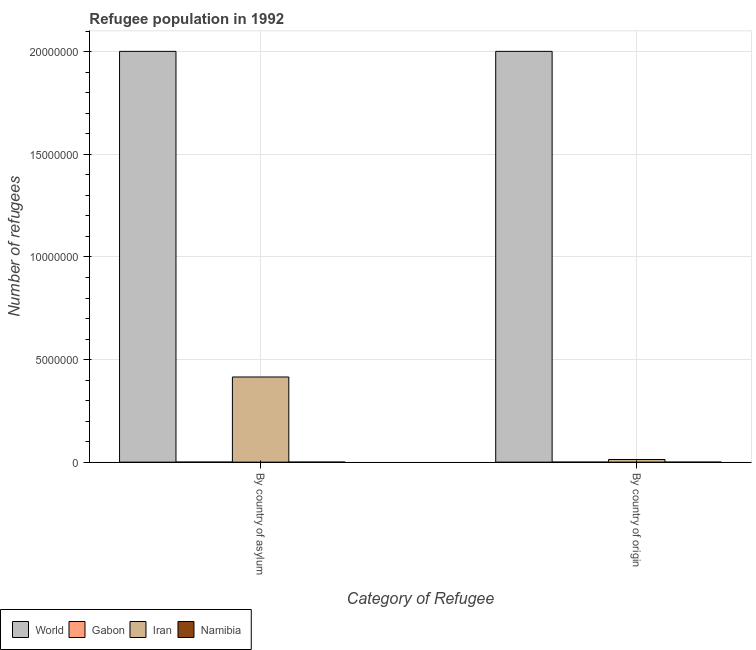How many groups of bars are there?
Make the answer very short. 2. Are the number of bars per tick equal to the number of legend labels?
Make the answer very short. Yes. Are the number of bars on each tick of the X-axis equal?
Your response must be concise. Yes. What is the label of the 1st group of bars from the left?
Your answer should be compact. By country of asylum. What is the number of refugees by country of asylum in Namibia?
Keep it short and to the point. 171. Across all countries, what is the maximum number of refugees by country of asylum?
Provide a succinct answer. 2.00e+07. Across all countries, what is the minimum number of refugees by country of origin?
Offer a terse response. 15. In which country was the number of refugees by country of origin maximum?
Make the answer very short. World. In which country was the number of refugees by country of asylum minimum?
Offer a terse response. Namibia. What is the total number of refugees by country of origin in the graph?
Your response must be concise. 2.02e+07. What is the difference between the number of refugees by country of origin in Gabon and that in World?
Offer a very short reply. -2.00e+07. What is the difference between the number of refugees by country of origin in Namibia and the number of refugees by country of asylum in World?
Ensure brevity in your answer.  -2.00e+07. What is the average number of refugees by country of origin per country?
Keep it short and to the point. 5.04e+06. What is the difference between the number of refugees by country of origin and number of refugees by country of asylum in Gabon?
Keep it short and to the point. -255. In how many countries, is the number of refugees by country of asylum greater than 8000000 ?
Offer a very short reply. 1. What is the ratio of the number of refugees by country of origin in Iran to that in Namibia?
Provide a succinct answer. 8585.4. In how many countries, is the number of refugees by country of origin greater than the average number of refugees by country of origin taken over all countries?
Ensure brevity in your answer.  1. What does the 2nd bar from the left in By country of asylum represents?
Give a very brief answer. Gabon. What does the 2nd bar from the right in By country of origin represents?
Give a very brief answer. Iran. How many bars are there?
Offer a very short reply. 8. Are all the bars in the graph horizontal?
Your answer should be compact. No. Are the values on the major ticks of Y-axis written in scientific E-notation?
Make the answer very short. No. Does the graph contain any zero values?
Ensure brevity in your answer.  No. Where does the legend appear in the graph?
Keep it short and to the point. Bottom left. How many legend labels are there?
Provide a succinct answer. 4. What is the title of the graph?
Ensure brevity in your answer.  Refugee population in 1992. Does "Tuvalu" appear as one of the legend labels in the graph?
Offer a very short reply. No. What is the label or title of the X-axis?
Make the answer very short. Category of Refugee. What is the label or title of the Y-axis?
Your answer should be compact. Number of refugees. What is the Number of refugees in World in By country of asylum?
Your answer should be compact. 2.00e+07. What is the Number of refugees in Gabon in By country of asylum?
Provide a succinct answer. 272. What is the Number of refugees of Iran in By country of asylum?
Keep it short and to the point. 4.15e+06. What is the Number of refugees of Namibia in By country of asylum?
Your response must be concise. 171. What is the Number of refugees in World in By country of origin?
Give a very brief answer. 2.00e+07. What is the Number of refugees of Gabon in By country of origin?
Ensure brevity in your answer.  17. What is the Number of refugees of Iran in By country of origin?
Ensure brevity in your answer.  1.29e+05. What is the Number of refugees in Namibia in By country of origin?
Make the answer very short. 15. Across all Category of Refugee, what is the maximum Number of refugees of World?
Your answer should be very brief. 2.00e+07. Across all Category of Refugee, what is the maximum Number of refugees in Gabon?
Provide a short and direct response. 272. Across all Category of Refugee, what is the maximum Number of refugees of Iran?
Offer a terse response. 4.15e+06. Across all Category of Refugee, what is the maximum Number of refugees in Namibia?
Make the answer very short. 171. Across all Category of Refugee, what is the minimum Number of refugees of World?
Your response must be concise. 2.00e+07. Across all Category of Refugee, what is the minimum Number of refugees of Iran?
Your answer should be very brief. 1.29e+05. What is the total Number of refugees of World in the graph?
Your answer should be very brief. 4.00e+07. What is the total Number of refugees of Gabon in the graph?
Offer a terse response. 289. What is the total Number of refugees in Iran in the graph?
Your response must be concise. 4.28e+06. What is the total Number of refugees of Namibia in the graph?
Give a very brief answer. 186. What is the difference between the Number of refugees of Gabon in By country of asylum and that in By country of origin?
Your answer should be compact. 255. What is the difference between the Number of refugees of Iran in By country of asylum and that in By country of origin?
Provide a short and direct response. 4.02e+06. What is the difference between the Number of refugees of Namibia in By country of asylum and that in By country of origin?
Your answer should be compact. 156. What is the difference between the Number of refugees of World in By country of asylum and the Number of refugees of Gabon in By country of origin?
Your answer should be compact. 2.00e+07. What is the difference between the Number of refugees in World in By country of asylum and the Number of refugees in Iran in By country of origin?
Provide a short and direct response. 1.99e+07. What is the difference between the Number of refugees in World in By country of asylum and the Number of refugees in Namibia in By country of origin?
Your answer should be very brief. 2.00e+07. What is the difference between the Number of refugees in Gabon in By country of asylum and the Number of refugees in Iran in By country of origin?
Keep it short and to the point. -1.29e+05. What is the difference between the Number of refugees in Gabon in By country of asylum and the Number of refugees in Namibia in By country of origin?
Provide a succinct answer. 257. What is the difference between the Number of refugees of Iran in By country of asylum and the Number of refugees of Namibia in By country of origin?
Offer a terse response. 4.15e+06. What is the average Number of refugees in World per Category of Refugee?
Give a very brief answer. 2.00e+07. What is the average Number of refugees in Gabon per Category of Refugee?
Your response must be concise. 144.5. What is the average Number of refugees of Iran per Category of Refugee?
Offer a very short reply. 2.14e+06. What is the average Number of refugees of Namibia per Category of Refugee?
Your response must be concise. 93. What is the difference between the Number of refugees in World and Number of refugees in Gabon in By country of asylum?
Provide a succinct answer. 2.00e+07. What is the difference between the Number of refugees of World and Number of refugees of Iran in By country of asylum?
Provide a short and direct response. 1.59e+07. What is the difference between the Number of refugees in World and Number of refugees in Namibia in By country of asylum?
Make the answer very short. 2.00e+07. What is the difference between the Number of refugees of Gabon and Number of refugees of Iran in By country of asylum?
Offer a very short reply. -4.15e+06. What is the difference between the Number of refugees of Gabon and Number of refugees of Namibia in By country of asylum?
Your answer should be compact. 101. What is the difference between the Number of refugees in Iran and Number of refugees in Namibia in By country of asylum?
Ensure brevity in your answer.  4.15e+06. What is the difference between the Number of refugees in World and Number of refugees in Gabon in By country of origin?
Offer a terse response. 2.00e+07. What is the difference between the Number of refugees in World and Number of refugees in Iran in By country of origin?
Your answer should be very brief. 1.99e+07. What is the difference between the Number of refugees in World and Number of refugees in Namibia in By country of origin?
Your response must be concise. 2.00e+07. What is the difference between the Number of refugees of Gabon and Number of refugees of Iran in By country of origin?
Your response must be concise. -1.29e+05. What is the difference between the Number of refugees in Iran and Number of refugees in Namibia in By country of origin?
Keep it short and to the point. 1.29e+05. What is the ratio of the Number of refugees in World in By country of asylum to that in By country of origin?
Keep it short and to the point. 1. What is the ratio of the Number of refugees in Gabon in By country of asylum to that in By country of origin?
Offer a terse response. 16. What is the ratio of the Number of refugees of Iran in By country of asylum to that in By country of origin?
Your answer should be very brief. 32.23. What is the difference between the highest and the second highest Number of refugees of World?
Ensure brevity in your answer.  0. What is the difference between the highest and the second highest Number of refugees in Gabon?
Provide a short and direct response. 255. What is the difference between the highest and the second highest Number of refugees in Iran?
Ensure brevity in your answer.  4.02e+06. What is the difference between the highest and the second highest Number of refugees in Namibia?
Offer a very short reply. 156. What is the difference between the highest and the lowest Number of refugees in World?
Provide a succinct answer. 0. What is the difference between the highest and the lowest Number of refugees in Gabon?
Keep it short and to the point. 255. What is the difference between the highest and the lowest Number of refugees in Iran?
Your answer should be very brief. 4.02e+06. What is the difference between the highest and the lowest Number of refugees of Namibia?
Provide a short and direct response. 156. 